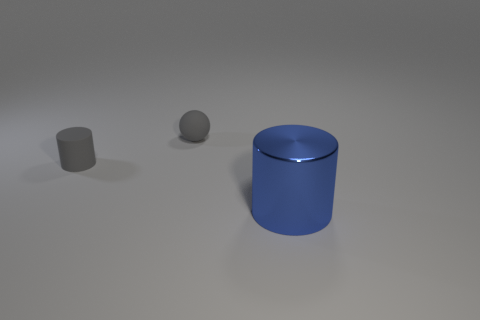Is there anything else that has the same size as the blue cylinder?
Your response must be concise. No. Is there anything else that is made of the same material as the small gray ball?
Your answer should be compact. Yes. What is the color of the matte thing that is the same size as the gray rubber cylinder?
Keep it short and to the point. Gray. Do the large cylinder and the small rubber object that is left of the small matte ball have the same color?
Offer a very short reply. No. The gray thing that is on the left side of the matte thing right of the matte cylinder is made of what material?
Make the answer very short. Rubber. How many objects are both right of the small cylinder and to the left of the large blue metal cylinder?
Your answer should be compact. 1. How many other objects are the same size as the matte cylinder?
Your answer should be very brief. 1. Do the object to the left of the small rubber ball and the object that is to the right of the small gray ball have the same shape?
Your answer should be very brief. Yes. There is a sphere; are there any small matte balls in front of it?
Make the answer very short. No. There is a tiny matte object that is the same shape as the big blue metallic thing; what is its color?
Offer a terse response. Gray. 